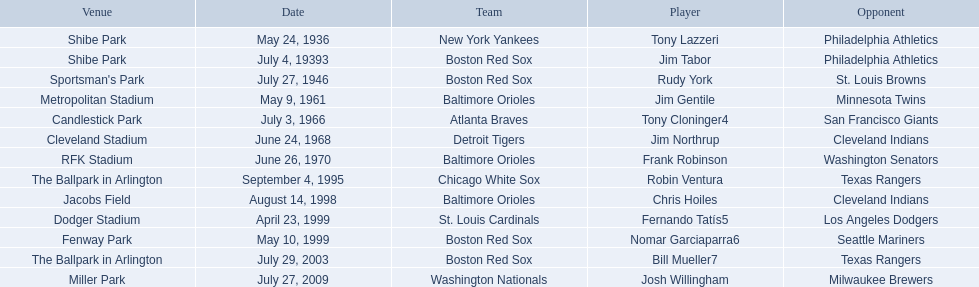What are the names of all the players? Tony Lazzeri, Jim Tabor, Rudy York, Jim Gentile, Tony Cloninger4, Jim Northrup, Frank Robinson, Robin Ventura, Chris Hoiles, Fernando Tatís5, Nomar Garciaparra6, Bill Mueller7, Josh Willingham. What are the names of all the teams holding home run records? New York Yankees, Boston Red Sox, Baltimore Orioles, Atlanta Braves, Detroit Tigers, Chicago White Sox, St. Louis Cardinals, Washington Nationals. Which player played for the new york yankees? Tony Lazzeri. 